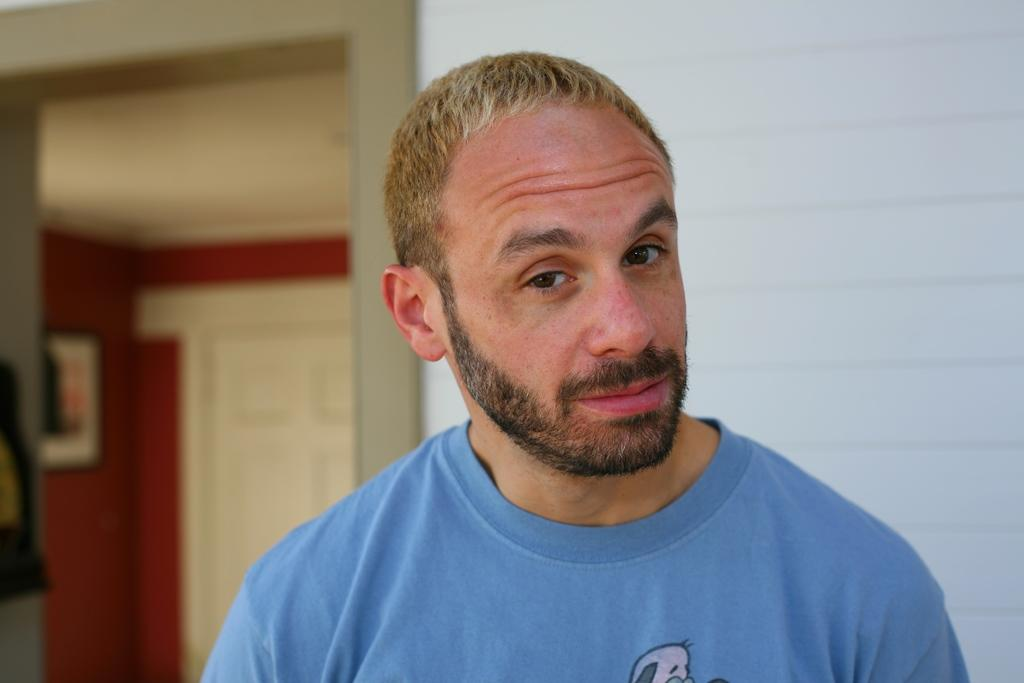Who is present in the image? There is a man in the image. What is the man wearing? The man is wearing a blue T-shirt. What can be seen in the background of the image? There is a wall, a door, and a board in the background of the image. What type of chalk is the man using to draw on the board in the image? There is no chalk present in the image, nor is the man drawing on the board. 